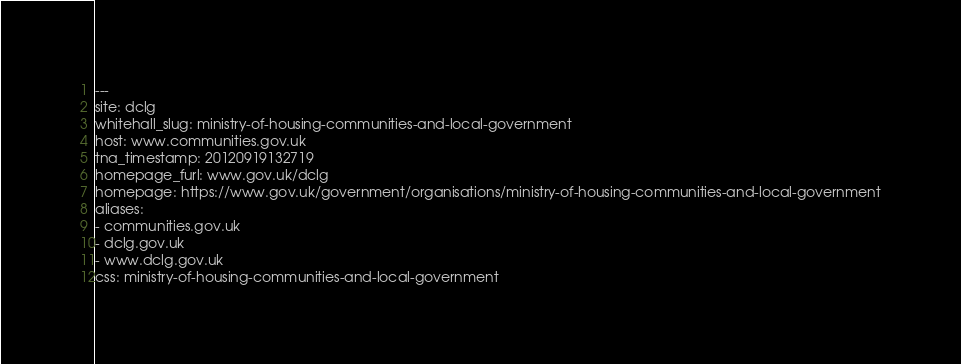<code> <loc_0><loc_0><loc_500><loc_500><_YAML_>---
site: dclg
whitehall_slug: ministry-of-housing-communities-and-local-government
host: www.communities.gov.uk
tna_timestamp: 20120919132719
homepage_furl: www.gov.uk/dclg
homepage: https://www.gov.uk/government/organisations/ministry-of-housing-communities-and-local-government
aliases:
- communities.gov.uk
- dclg.gov.uk
- www.dclg.gov.uk
css: ministry-of-housing-communities-and-local-government
</code> 